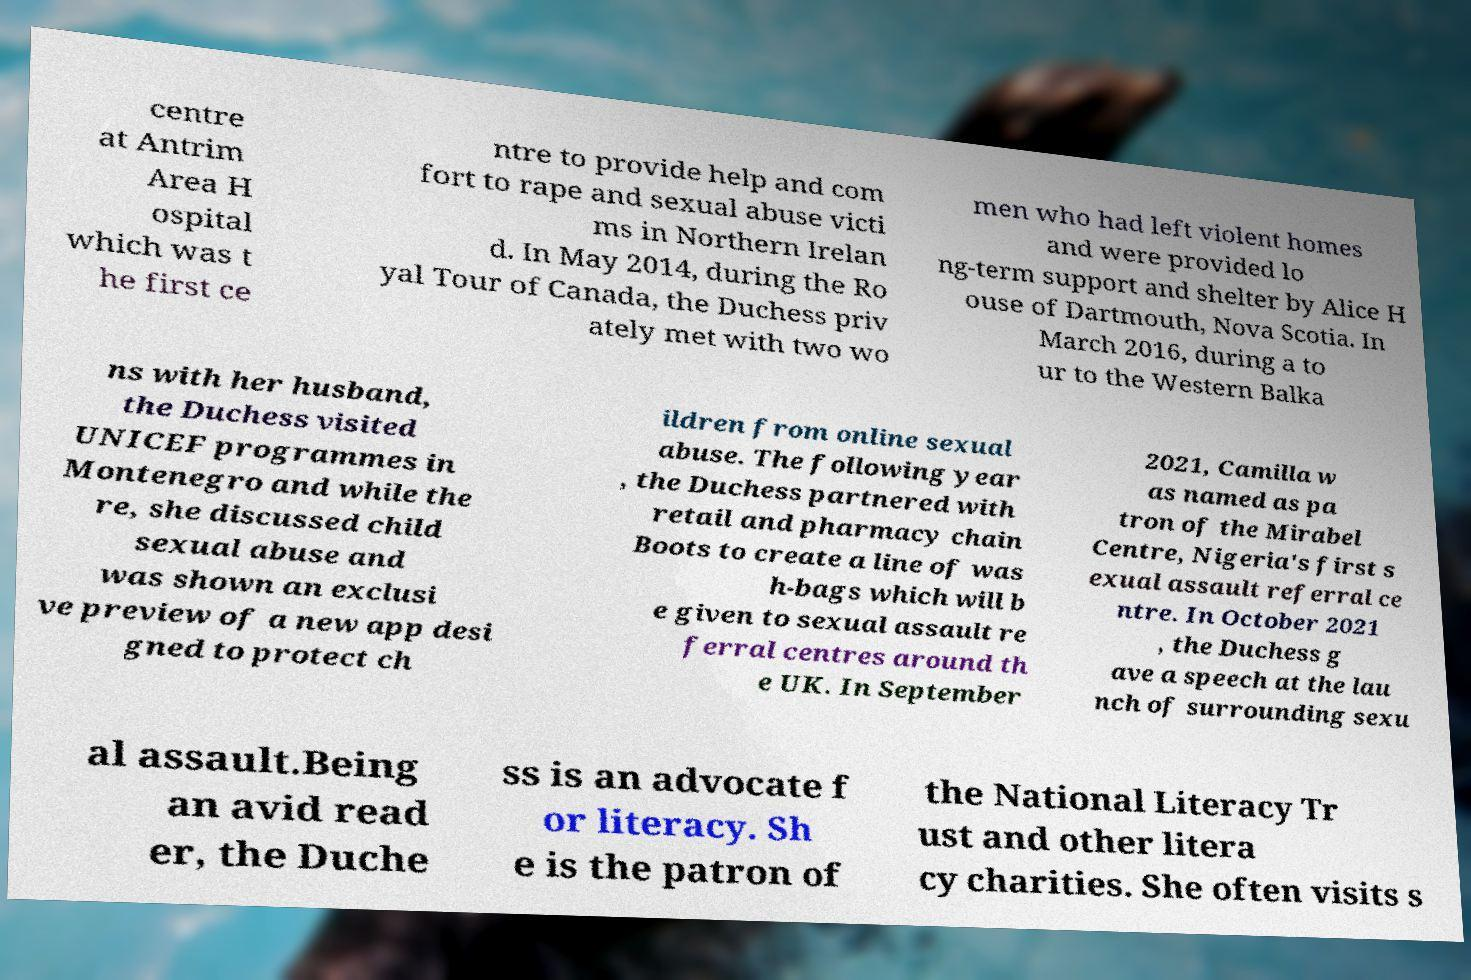There's text embedded in this image that I need extracted. Can you transcribe it verbatim? centre at Antrim Area H ospital which was t he first ce ntre to provide help and com fort to rape and sexual abuse victi ms in Northern Irelan d. In May 2014, during the Ro yal Tour of Canada, the Duchess priv ately met with two wo men who had left violent homes and were provided lo ng-term support and shelter by Alice H ouse of Dartmouth, Nova Scotia. In March 2016, during a to ur to the Western Balka ns with her husband, the Duchess visited UNICEF programmes in Montenegro and while the re, she discussed child sexual abuse and was shown an exclusi ve preview of a new app desi gned to protect ch ildren from online sexual abuse. The following year , the Duchess partnered with retail and pharmacy chain Boots to create a line of was h-bags which will b e given to sexual assault re ferral centres around th e UK. In September 2021, Camilla w as named as pa tron of the Mirabel Centre, Nigeria's first s exual assault referral ce ntre. In October 2021 , the Duchess g ave a speech at the lau nch of surrounding sexu al assault.Being an avid read er, the Duche ss is an advocate f or literacy. Sh e is the patron of the National Literacy Tr ust and other litera cy charities. She often visits s 